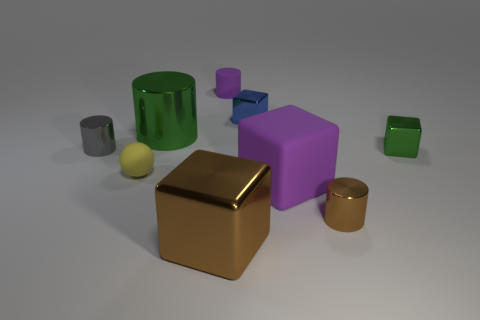Subtract all blue metallic cubes. How many cubes are left? 3 Subtract 2 cylinders. How many cylinders are left? 2 Subtract all brown cylinders. How many cylinders are left? 3 Add 1 tiny rubber spheres. How many objects exist? 10 Subtract all brown cubes. Subtract all purple cylinders. How many cubes are left? 3 Subtract 0 green spheres. How many objects are left? 9 Subtract all spheres. How many objects are left? 8 Subtract all tiny green metal things. Subtract all big rubber blocks. How many objects are left? 7 Add 2 gray objects. How many gray objects are left? 3 Add 7 blue shiny things. How many blue shiny things exist? 8 